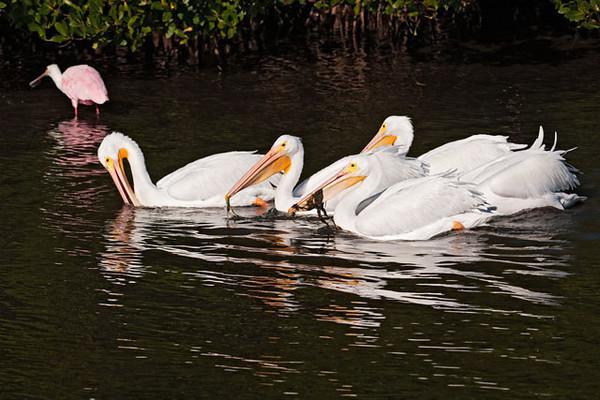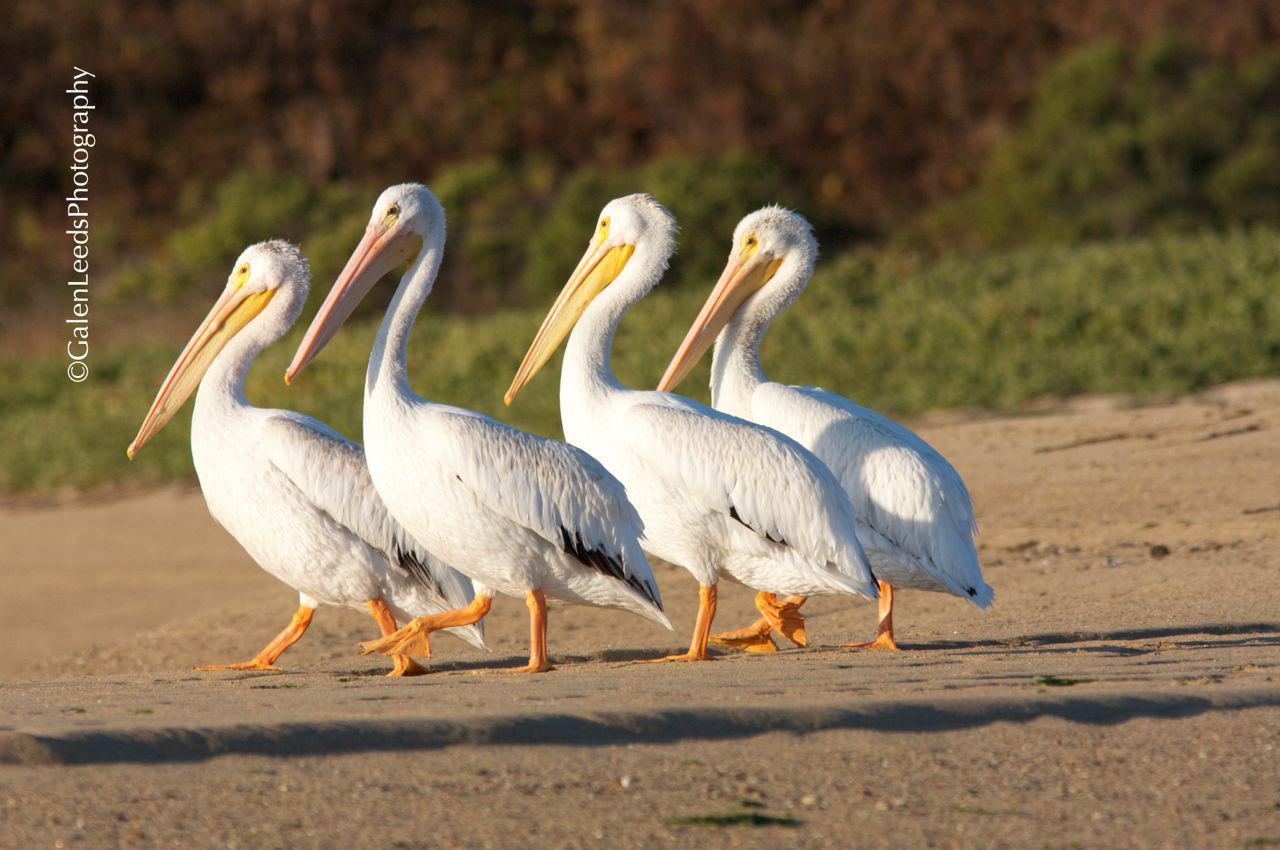The first image is the image on the left, the second image is the image on the right. Given the left and right images, does the statement "Left image shows left-facing pelicans floating on the water." hold true? Answer yes or no. Yes. 